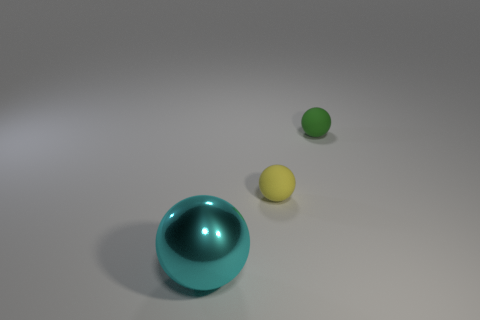Is the number of tiny matte balls on the left side of the green thing greater than the number of yellow matte things behind the metallic ball?
Offer a very short reply. No. How many blue objects are either large metal things or rubber balls?
Keep it short and to the point. 0. What is the size of the yellow ball that is the same material as the tiny green sphere?
Provide a short and direct response. Small. Is the tiny object that is behind the yellow matte thing made of the same material as the small sphere that is in front of the green object?
Keep it short and to the point. Yes. What number of cylinders are yellow objects or brown objects?
Offer a very short reply. 0. There is a tiny matte thing that is in front of the small object behind the tiny yellow object; how many tiny yellow rubber things are to the left of it?
Your answer should be compact. 0. There is a large cyan thing that is the same shape as the yellow object; what material is it?
Provide a succinct answer. Metal. Are there any other things that have the same material as the big ball?
Provide a succinct answer. No. There is a tiny sphere that is on the left side of the tiny green ball; what color is it?
Make the answer very short. Yellow. Is the material of the tiny green object the same as the small ball on the left side of the green ball?
Ensure brevity in your answer.  Yes. 